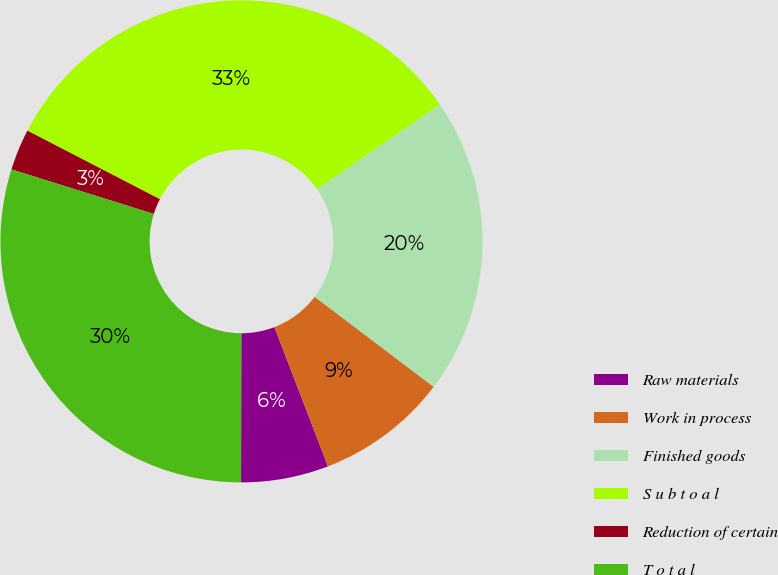Convert chart. <chart><loc_0><loc_0><loc_500><loc_500><pie_chart><fcel>Raw materials<fcel>Work in process<fcel>Finished goods<fcel>S u b t o a l<fcel>Reduction of certain<fcel>T o t a l<nl><fcel>5.87%<fcel>8.85%<fcel>19.93%<fcel>32.78%<fcel>2.77%<fcel>29.8%<nl></chart> 